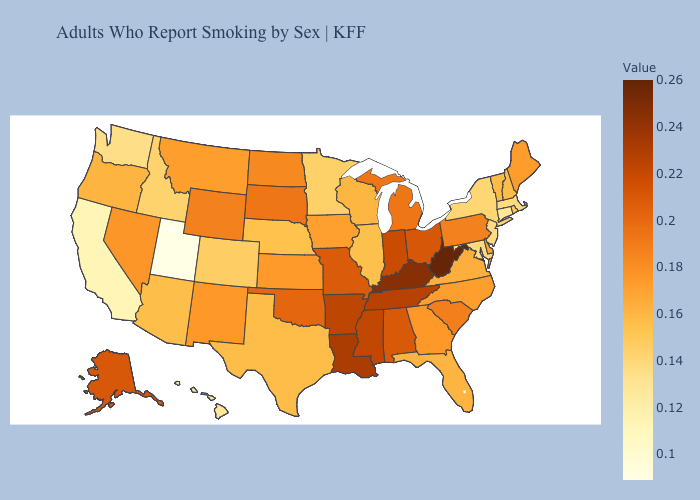Does California have the lowest value in the USA?
Answer briefly. No. Which states have the lowest value in the Northeast?
Quick response, please. Connecticut. Which states have the lowest value in the Northeast?
Keep it brief. Connecticut. 